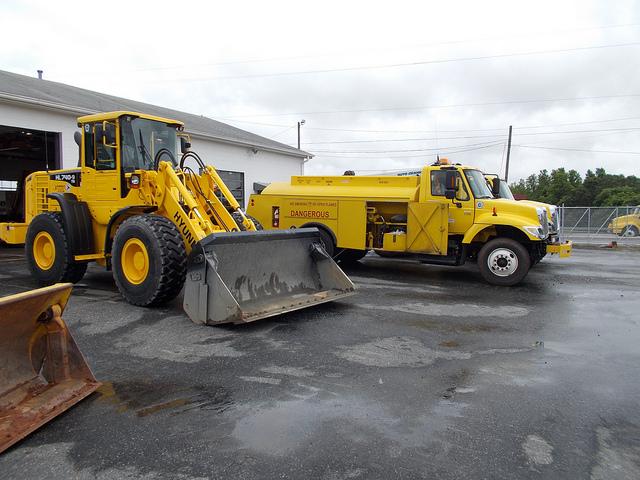What sort of dog would complete this picture?
Short answer required. Doberman. Where is the truck sitting?
Answer briefly. Parking lot. How many yellow trucks are parked?
Answer briefly. 2. Is the ground wet?
Concise answer only. Yes. What is the color of the trucks?
Concise answer only. Yellow. 